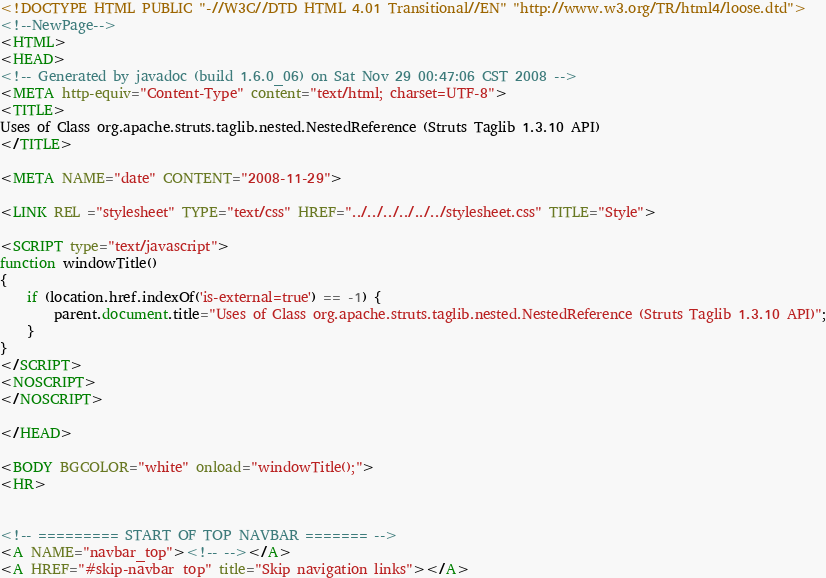<code> <loc_0><loc_0><loc_500><loc_500><_HTML_><!DOCTYPE HTML PUBLIC "-//W3C//DTD HTML 4.01 Transitional//EN" "http://www.w3.org/TR/html4/loose.dtd">
<!--NewPage-->
<HTML>
<HEAD>
<!-- Generated by javadoc (build 1.6.0_06) on Sat Nov 29 00:47:06 CST 2008 -->
<META http-equiv="Content-Type" content="text/html; charset=UTF-8">
<TITLE>
Uses of Class org.apache.struts.taglib.nested.NestedReference (Struts Taglib 1.3.10 API)
</TITLE>

<META NAME="date" CONTENT="2008-11-29">

<LINK REL ="stylesheet" TYPE="text/css" HREF="../../../../../../stylesheet.css" TITLE="Style">

<SCRIPT type="text/javascript">
function windowTitle()
{
    if (location.href.indexOf('is-external=true') == -1) {
        parent.document.title="Uses of Class org.apache.struts.taglib.nested.NestedReference (Struts Taglib 1.3.10 API)";
    }
}
</SCRIPT>
<NOSCRIPT>
</NOSCRIPT>

</HEAD>

<BODY BGCOLOR="white" onload="windowTitle();">
<HR>


<!-- ========= START OF TOP NAVBAR ======= -->
<A NAME="navbar_top"><!-- --></A>
<A HREF="#skip-navbar_top" title="Skip navigation links"></A></code> 